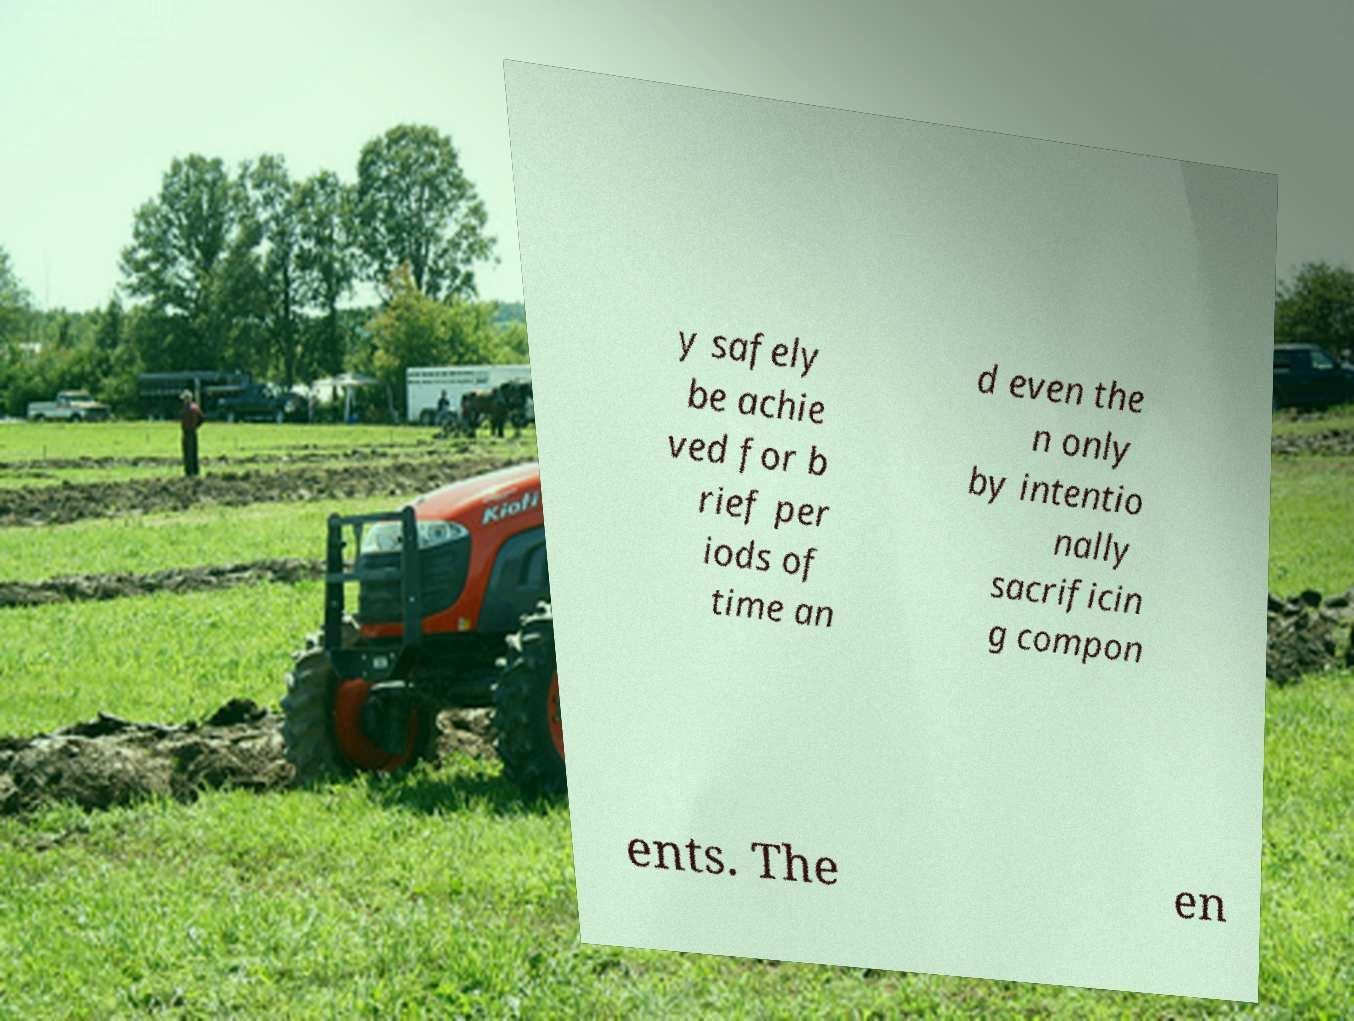Please identify and transcribe the text found in this image. y safely be achie ved for b rief per iods of time an d even the n only by intentio nally sacrificin g compon ents. The en 